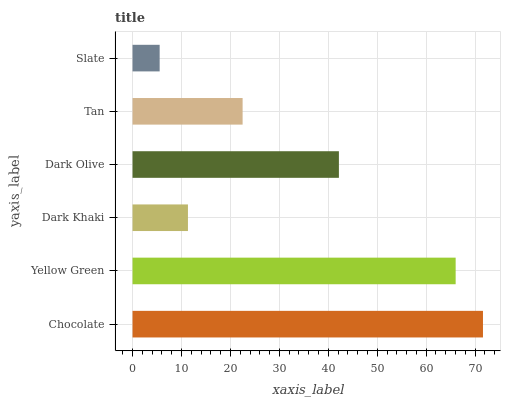Is Slate the minimum?
Answer yes or no. Yes. Is Chocolate the maximum?
Answer yes or no. Yes. Is Yellow Green the minimum?
Answer yes or no. No. Is Yellow Green the maximum?
Answer yes or no. No. Is Chocolate greater than Yellow Green?
Answer yes or no. Yes. Is Yellow Green less than Chocolate?
Answer yes or no. Yes. Is Yellow Green greater than Chocolate?
Answer yes or no. No. Is Chocolate less than Yellow Green?
Answer yes or no. No. Is Dark Olive the high median?
Answer yes or no. Yes. Is Tan the low median?
Answer yes or no. Yes. Is Dark Khaki the high median?
Answer yes or no. No. Is Yellow Green the low median?
Answer yes or no. No. 